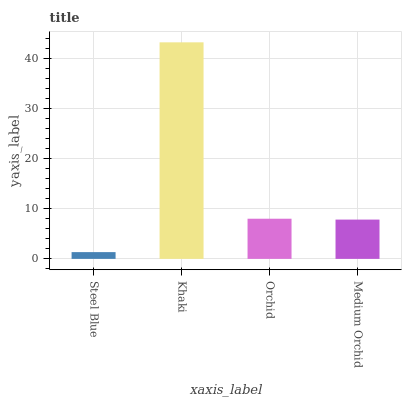Is Steel Blue the minimum?
Answer yes or no. Yes. Is Khaki the maximum?
Answer yes or no. Yes. Is Orchid the minimum?
Answer yes or no. No. Is Orchid the maximum?
Answer yes or no. No. Is Khaki greater than Orchid?
Answer yes or no. Yes. Is Orchid less than Khaki?
Answer yes or no. Yes. Is Orchid greater than Khaki?
Answer yes or no. No. Is Khaki less than Orchid?
Answer yes or no. No. Is Orchid the high median?
Answer yes or no. Yes. Is Medium Orchid the low median?
Answer yes or no. Yes. Is Khaki the high median?
Answer yes or no. No. Is Steel Blue the low median?
Answer yes or no. No. 